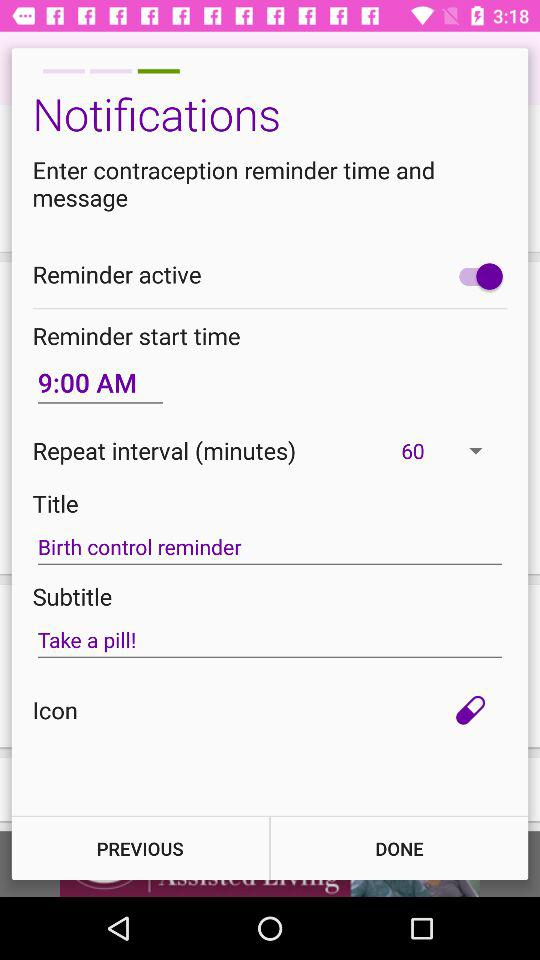What is the reminder start time? The reminder start time is 9:00 AM. 